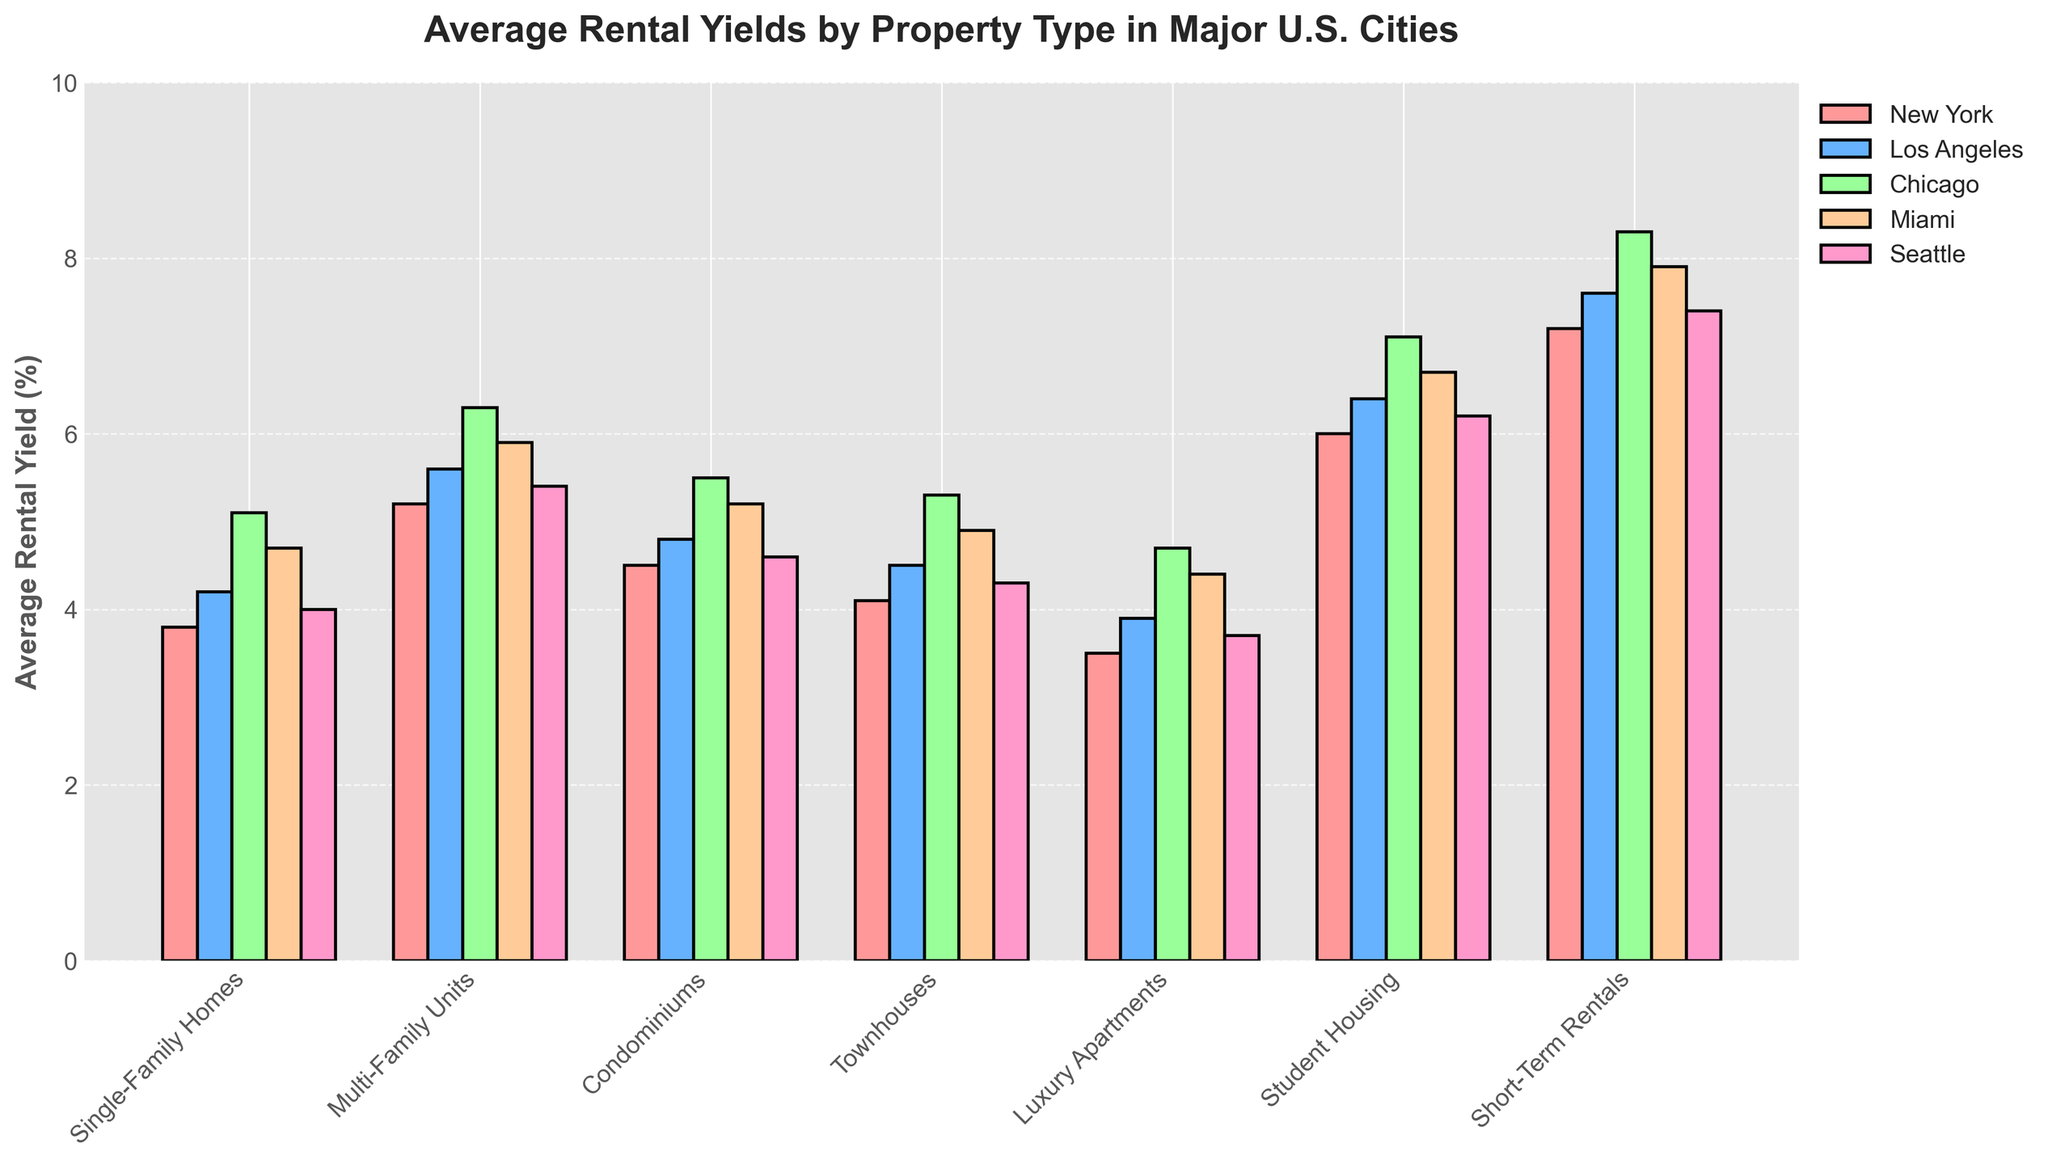Which property type has the highest average rental yield in New York? The shortest bar for New York City indicates the type with the highest rental yield visually, which is Student Housing.
Answer: Student Housing By how much does the average rental yield of Short-Term Rentals in Miami exceed that of Luxury Apartments in Seattle? Looking at the heights of the respective bars for Miami and Seattle, Short-Term Rentals in Miami is 7.9%, and Luxury Apartments in Seattle is 3.7%. The difference is 7.9 - 3.7 = 4.2%.
Answer: 4.2% Which city offers the highest average rental yield for Multi-Family Units? Observe the bars representing Multi-Family Units for each city and find the highest bar. The tallest bar for Multi-Family Units is in Chicago.
Answer: Chicago What is the combined average rental yield for Single-Family Homes and Condominiums in Miami? Locate the bars for Single-Family Homes and Condominiums in Miami. Then add their values: 4.7% + 5.2% = 9.9%.
Answer: 9.9% Compare the average rental yields for Townhouses in Seattle and Luxury Apartments in Los Angeles. Which is higher and by how much? Find the Townhouses bar in Seattle and the Luxury Apartments bar in Los Angeles. Seattle's Townhouses yield is 4.3%, and Los Angeles' Luxury Apartments yield is 3.9%. Difference is 4.3% - 3.9% = 0.4%. Townhouses in Seattle are higher.
Answer: Townhouses in Seattle by 0.4% Which property type has a consistently high rental yield across all cities? Identify the property type with bars consistently higher than the others across all cities. Short-Term Rentals have high bars in all cities.
Answer: Short-Term Rentals What is the average rental yield across all cities for Condominiums? Find the heights of the bars for Condominiums in all cities and calculate the average: (4.5 + 4.8 + 5.5 + 5.2 + 4.6) / 5 = 4.92%.
Answer: 4.92% How does the average rental yield of Single-Family Homes in Chicago compare to Multi-Family Units in New York? Compare the values: Single-Family Homes in Chicago is 5.1%, and Multi-Family Units in New York is 5.2%. Multi-Family Units in New York is higher than Single-Family Homes in Chicago by 0.1%.
Answer: New York by 0.1% Which property type in Los Angeles has the lowest average rental yield, and what is it? Identify the shortest bar in Los Angeles. The bar for Luxury Apartments is the lowest at 3.9%.
Answer: Luxury Apartments, 3.9% What is the range of average rental yields for Student Housing across all cities? Find the highest and lowest bars for Student Housing. The highest yield is 7.1% (Chicago), and the lowest is 6.0% (New York). Range is 7.1% - 6.0% = 1.1%.
Answer: 1.1% 